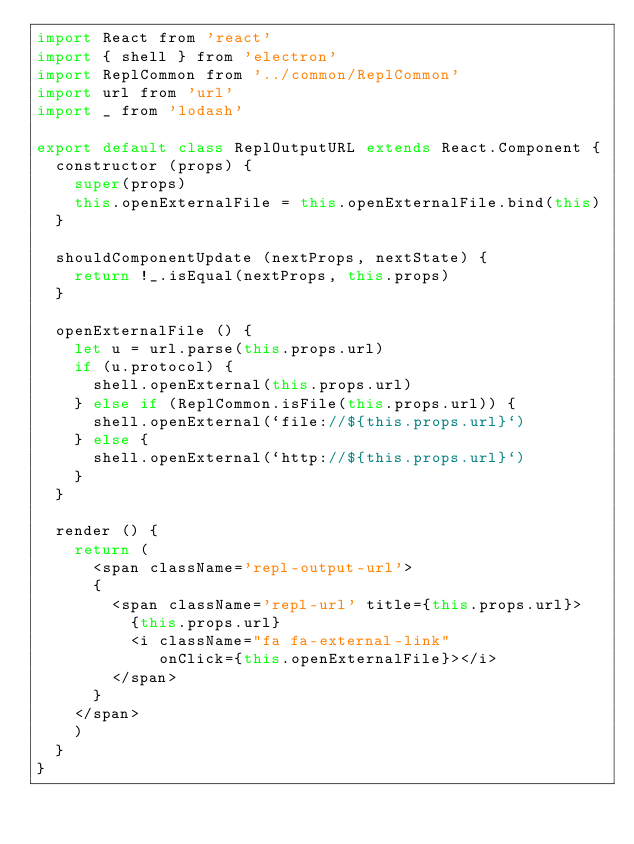<code> <loc_0><loc_0><loc_500><loc_500><_JavaScript_>import React from 'react'
import { shell } from 'electron'
import ReplCommon from '../common/ReplCommon'
import url from 'url'
import _ from 'lodash'

export default class ReplOutputURL extends React.Component {
  constructor (props) {
    super(props)
    this.openExternalFile = this.openExternalFile.bind(this)
  }
  
  shouldComponentUpdate (nextProps, nextState) {
    return !_.isEqual(nextProps, this.props)
  }
  
  openExternalFile () {
    let u = url.parse(this.props.url)
    if (u.protocol) {
      shell.openExternal(this.props.url)
    } else if (ReplCommon.isFile(this.props.url)) {
      shell.openExternal(`file://${this.props.url}`)
    } else {
      shell.openExternal(`http://${this.props.url}`)
    }
  }
  
  render () {
    return (
      <span className='repl-output-url'>
      {
        <span className='repl-url' title={this.props.url}>
          {this.props.url}
          <i className="fa fa-external-link"
             onClick={this.openExternalFile}></i>
        </span>
      }
    </span>
    )
  }
}
</code> 